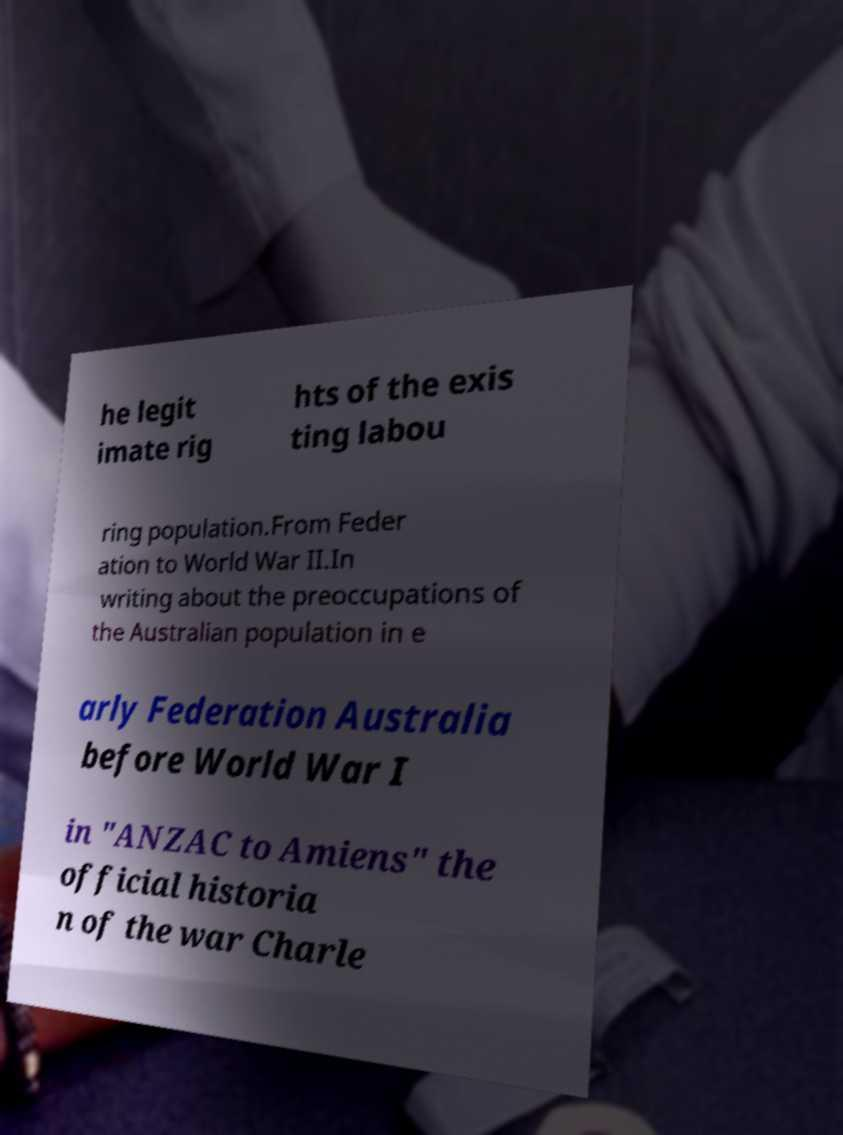Can you accurately transcribe the text from the provided image for me? he legit imate rig hts of the exis ting labou ring population.From Feder ation to World War II.In writing about the preoccupations of the Australian population in e arly Federation Australia before World War I in "ANZAC to Amiens" the official historia n of the war Charle 